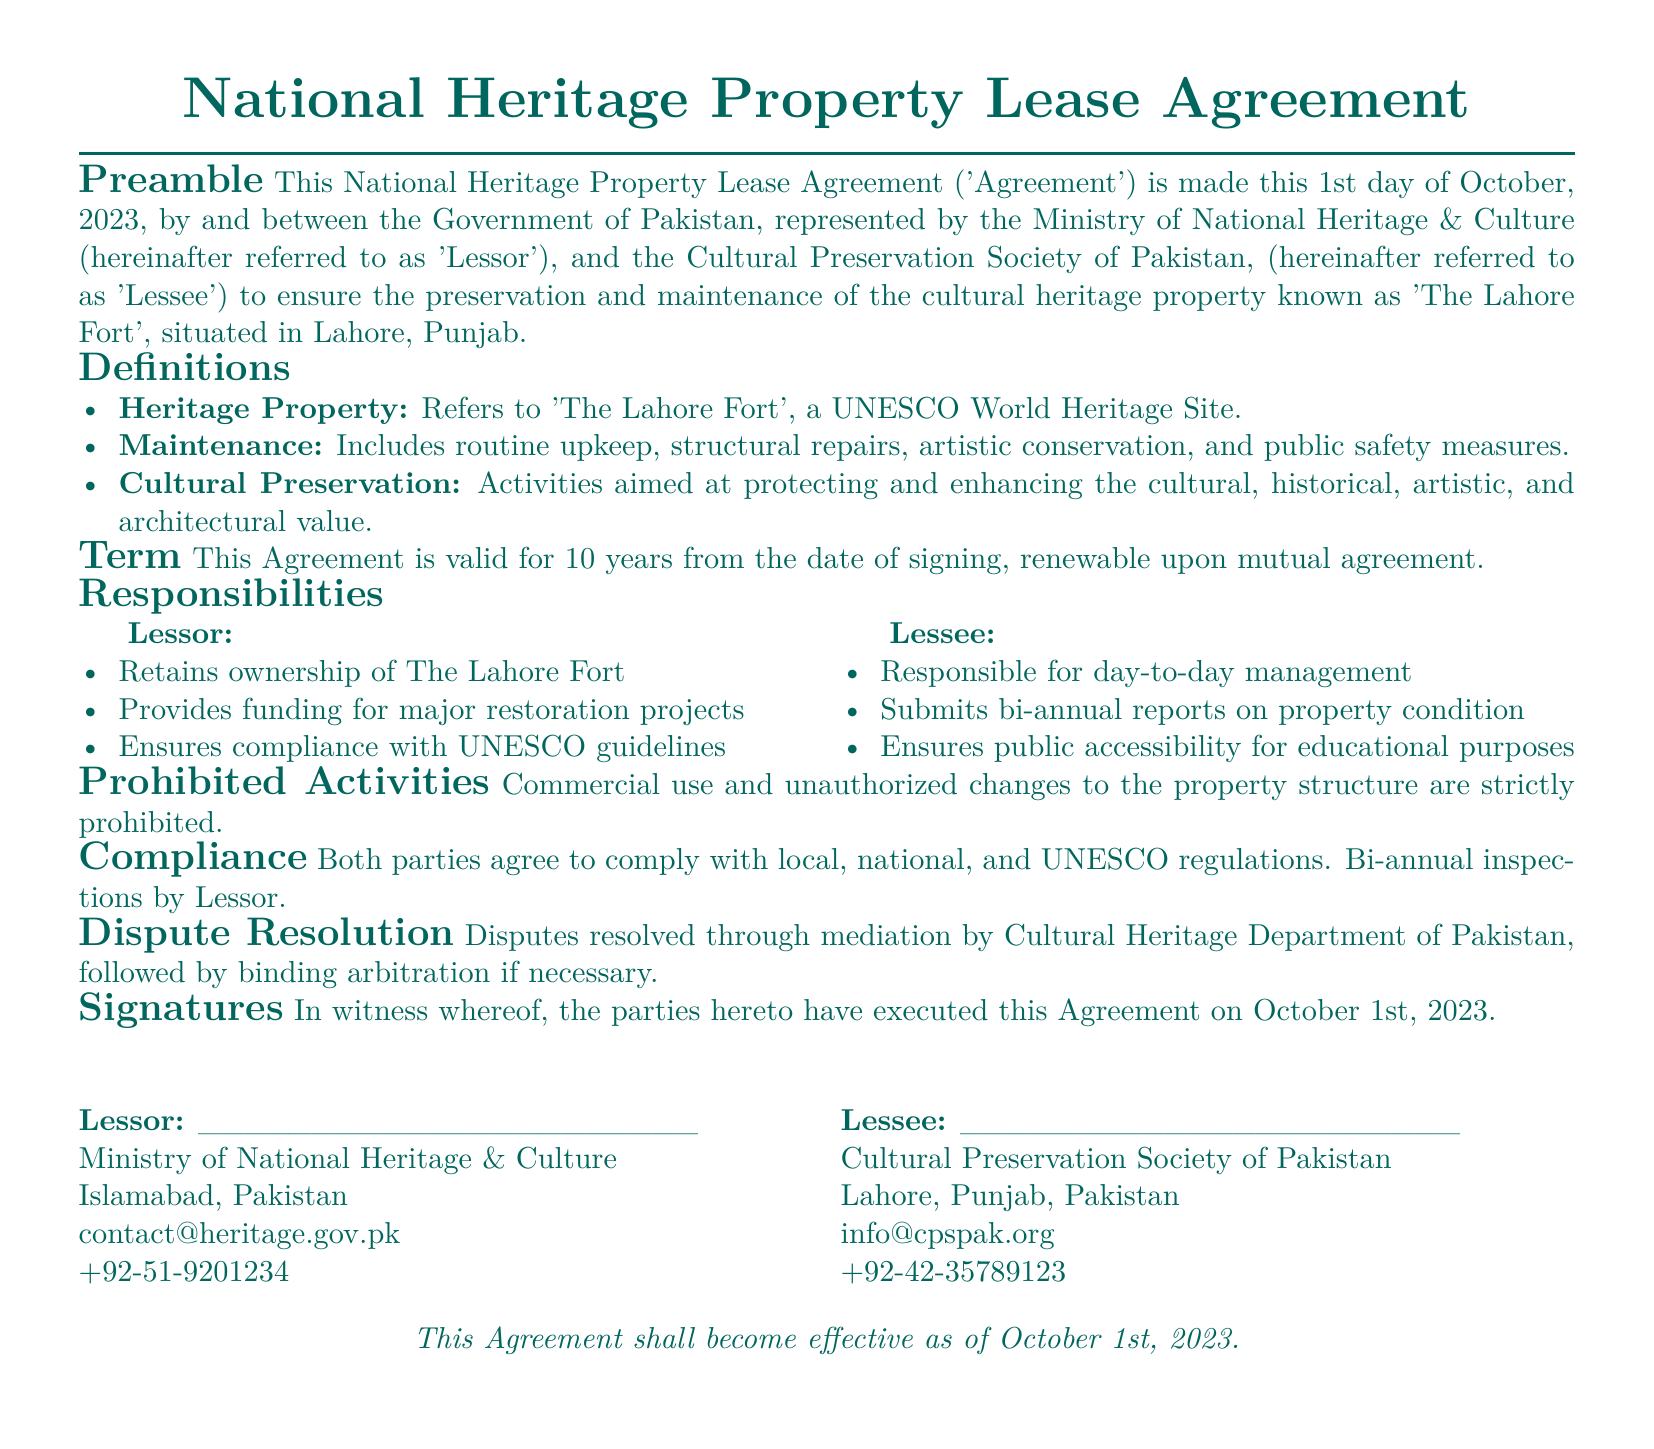what is the name of the heritage property? The document explicitly states that the heritage property is 'The Lahore Fort'.
Answer: The Lahore Fort who represents the Lessor in the agreement? The Lessor is represented by the Ministry of National Heritage & Culture, as indicated in the preamble.
Answer: Ministry of National Heritage & Culture what is the duration of the lease agreement? The term of the agreement is specified as 10 years from the date of signing.
Answer: 10 years how often must the Lessee submit reports on property condition? The agreement specifies that the Lessee must submit bi-annual reports.
Answer: bi-annual what types of activities are prohibited according to the document? The document states that commercial use and unauthorized changes to the property structure are strictly prohibited.
Answer: commercial use, unauthorized changes which department handles dispute resolution? The document indicates that disputes will be mediated by the Cultural Heritage Department of Pakistan.
Answer: Cultural Heritage Department of Pakistan when did the lease agreement become effective? The effectiveness of the agreement is stated as October 1st, 2023.
Answer: October 1st, 2023 who is responsible for funding major restoration projects? The document specifies that the Lessor is responsible for providing funding for major restoration projects.
Answer: Lessor what is the main purpose of this lease agreement? The primary purpose of this agreement is to ensure the preservation and maintenance of the cultural heritage property.
Answer: preservation and maintenance of cultural heritage 